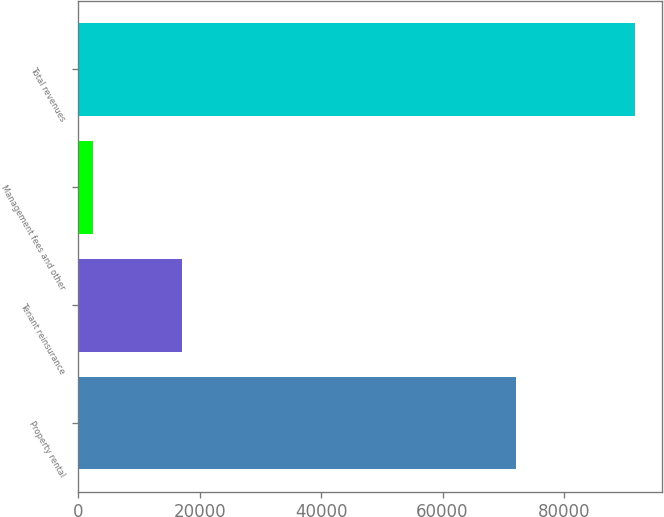Convert chart. <chart><loc_0><loc_0><loc_500><loc_500><bar_chart><fcel>Property rental<fcel>Tenant reinsurance<fcel>Management fees and other<fcel>Total revenues<nl><fcel>72111<fcel>17106<fcel>2378<fcel>91595<nl></chart> 